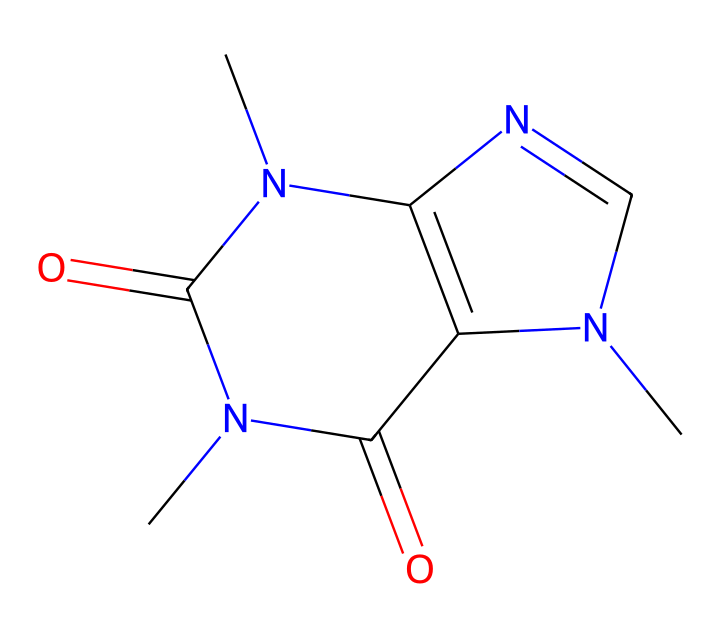What is the total number of nitrogen atoms in this compound? The SMILES representation includes two 'N' characters, indicating the presence of two nitrogen atoms in the structure.
Answer: two How many carbon atoms are present in the chemical? By counting the 'C' characters in the SMILES string, we find a total of six carbon atoms present in the compound's structure.
Answer: six What functional group is indicated by the presence of the 'C(=O)' moiety? The 'C(=O)' indicates a carbonyl group, which is characteristic of ketones or amides in this context; since both are present in this compound, it suggests multiple functionalities.
Answer: carbonyl group Does this compound contain any double bonds? The presence of '=' in the SMILES indicates double bonds; the structure contains at least two double bonds, suggesting conjugation and affecting its chemical properties.
Answer: yes Is this compound classified as a hypervalent compound? A hypervalent compound typically has a central atom that can expand its valence shell; the presence of the nitrogen atoms suggests multiple bonding scenarios, affirming its classification.
Answer: yes What type of derivatives is most likely to be present based on the structure? Given the nitrogen functionalities and carbonyls, this structure represents a derivative of nucleobases commonly found in energy-boosting compounds.
Answer: nucleobase 